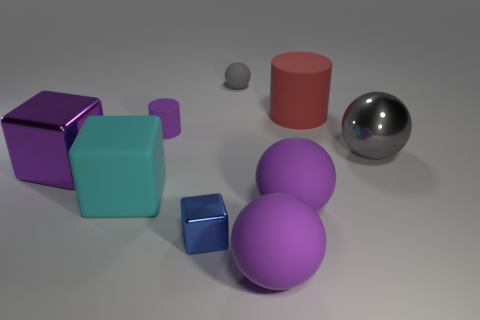Subtract all purple cylinders. Subtract all red blocks. How many cylinders are left? 1 Subtract all purple cubes. How many brown balls are left? 0 Add 4 grays. How many large cyans exist? 0 Subtract all large metallic things. Subtract all large red things. How many objects are left? 6 Add 7 big cylinders. How many big cylinders are left? 8 Add 5 cyan objects. How many cyan objects exist? 6 Add 1 gray spheres. How many objects exist? 10 Subtract all purple cylinders. How many cylinders are left? 1 Subtract all large cubes. How many cubes are left? 1 Subtract 1 blue cubes. How many objects are left? 8 